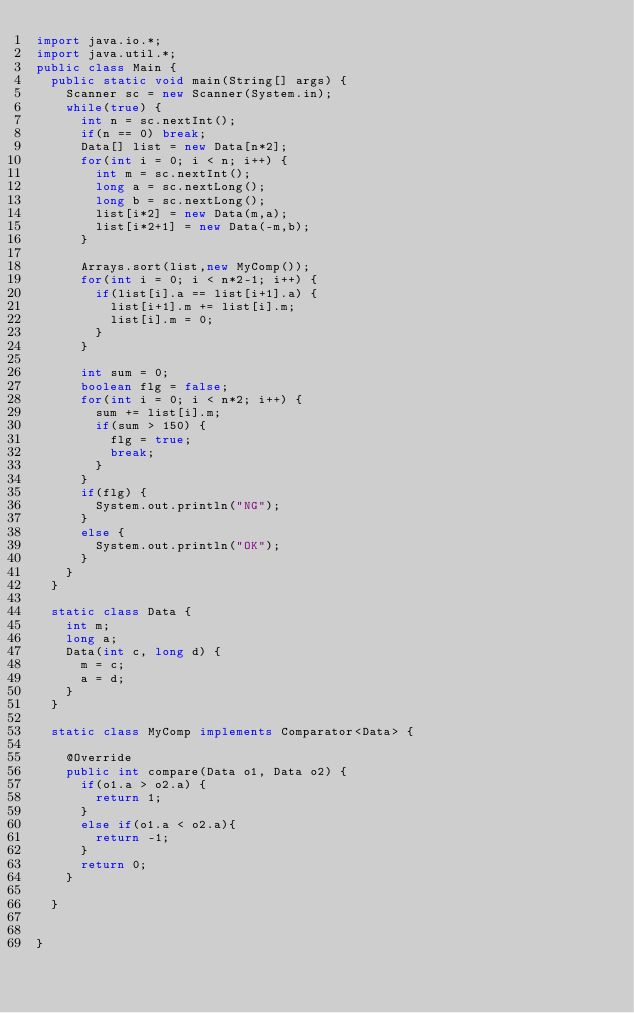Convert code to text. <code><loc_0><loc_0><loc_500><loc_500><_Java_>import java.io.*;
import java.util.*;
public class Main {
	public static void main(String[] args) {
		Scanner sc = new Scanner(System.in);
		while(true) {
			int n = sc.nextInt();
			if(n == 0) break;
			Data[] list = new Data[n*2];
			for(int i = 0; i < n; i++) {
				int m = sc.nextInt();
				long a = sc.nextLong();
				long b = sc.nextLong();
				list[i*2] = new Data(m,a);
				list[i*2+1] = new Data(-m,b);
			}
			
			Arrays.sort(list,new MyComp());
			for(int i = 0; i < n*2-1; i++) {
				if(list[i].a == list[i+1].a) {
					list[i+1].m += list[i].m;
					list[i].m = 0;
				}
			}
			
			int sum = 0;
			boolean flg = false;
			for(int i = 0; i < n*2; i++) {
				sum += list[i].m;
				if(sum > 150) {
					flg = true;
					break;
				}
			}
			if(flg) {
				System.out.println("NG");
			}
			else {
				System.out.println("OK");
			}
		}
	}
	
	static class Data {
		int m;
		long a;
		Data(int c, long d) {
			m = c;
			a = d;
		}
	}
	
	static class MyComp implements Comparator<Data> {

		@Override
		public int compare(Data o1, Data o2) {
			if(o1.a > o2.a) {
				return 1;
			}
			else if(o1.a < o2.a){
				return -1;
			}
			return 0;
		}
		
	}
	
		
}</code> 